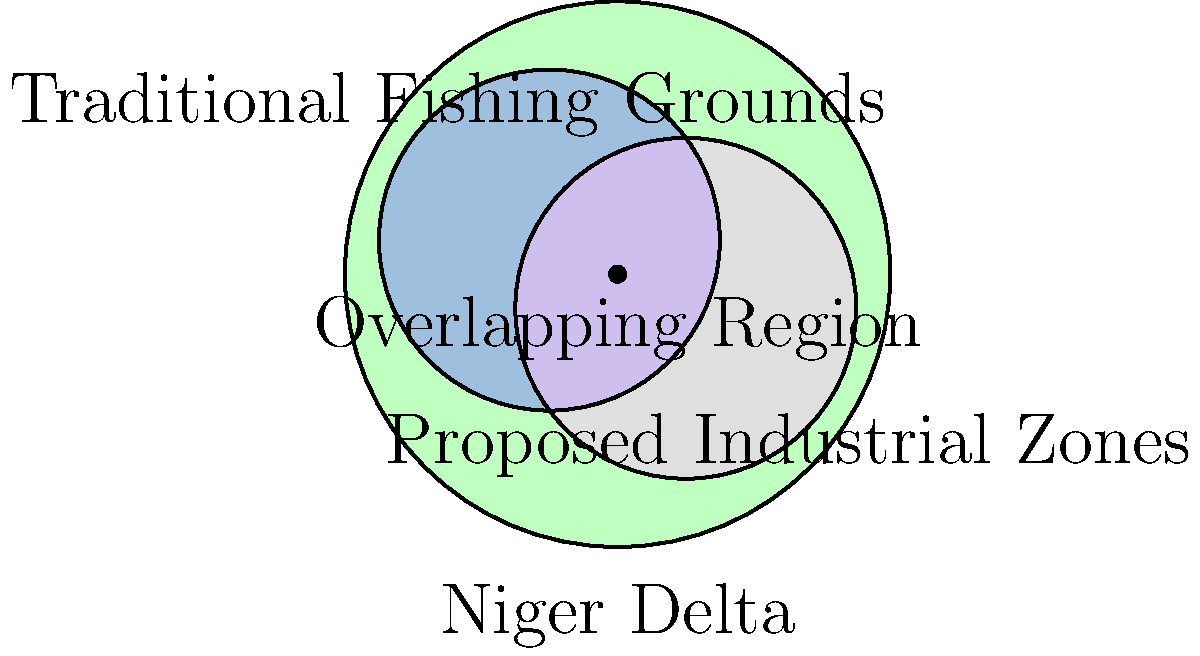Based on the map of the Niger Delta region, what is the approximate percentage of the traditional fishing grounds that overlap with the proposed industrial zones? To determine the percentage of overlap between traditional fishing grounds and proposed industrial zones, we need to follow these steps:

1. Observe the map carefully. The blue circle represents traditional fishing grounds, while the pink circle represents proposed industrial zones.

2. Identify the overlapping region, which is where the blue and pink circles intersect.

3. Estimate the area of overlap in relation to the total area of the traditional fishing grounds (blue circle).

4. The overlapping region appears to cover approximately 25% of the traditional fishing grounds.

5. This estimation is based on visual inspection, as the exact measurement would require more precise tools and data.

6. It's important to note that this overlap represents a significant portion of the traditional fishing grounds, which could have substantial impacts on the indigenous communities' livelihoods and cultural practices.
Answer: Approximately 25% 